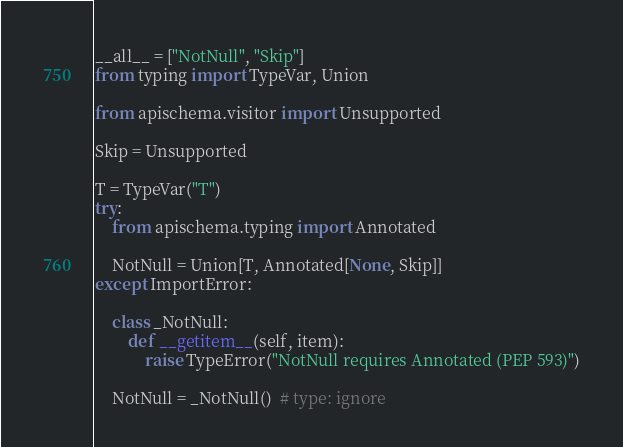Convert code to text. <code><loc_0><loc_0><loc_500><loc_500><_Python_>__all__ = ["NotNull", "Skip"]
from typing import TypeVar, Union

from apischema.visitor import Unsupported

Skip = Unsupported

T = TypeVar("T")
try:
    from apischema.typing import Annotated

    NotNull = Union[T, Annotated[None, Skip]]
except ImportError:

    class _NotNull:
        def __getitem__(self, item):
            raise TypeError("NotNull requires Annotated (PEP 593)")

    NotNull = _NotNull()  # type: ignore
</code> 